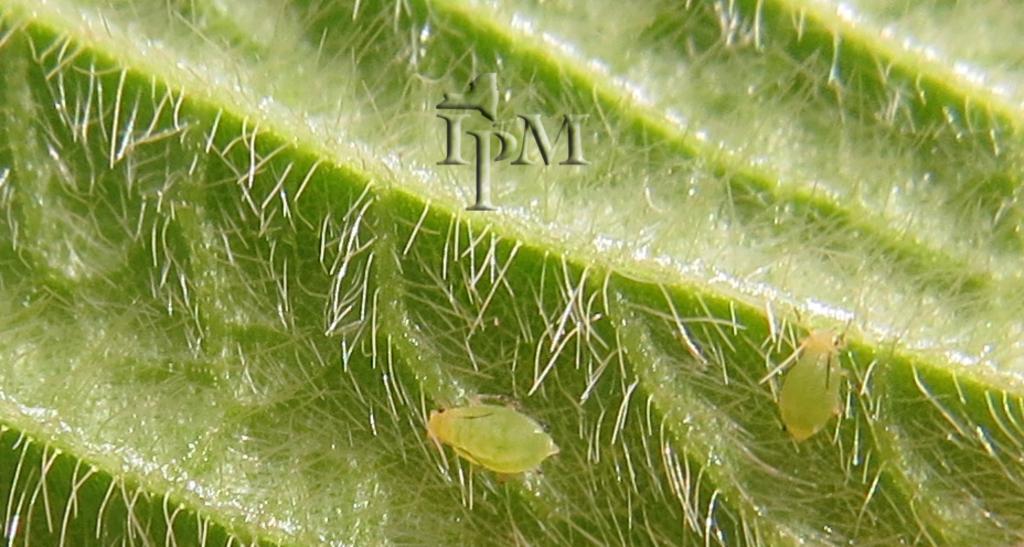Please provide a concise description of this image. In this image I can see two insects on the green color leaf and the insects are in green color. 